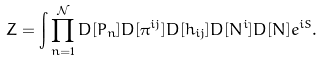Convert formula to latex. <formula><loc_0><loc_0><loc_500><loc_500>Z = \int \prod _ { n = 1 } ^ { \mathcal { N } } D [ P _ { n } ] D [ \pi ^ { i j } ] D [ h _ { i j } ] D [ N ^ { i } ] D [ N ] e ^ { i S } .</formula> 